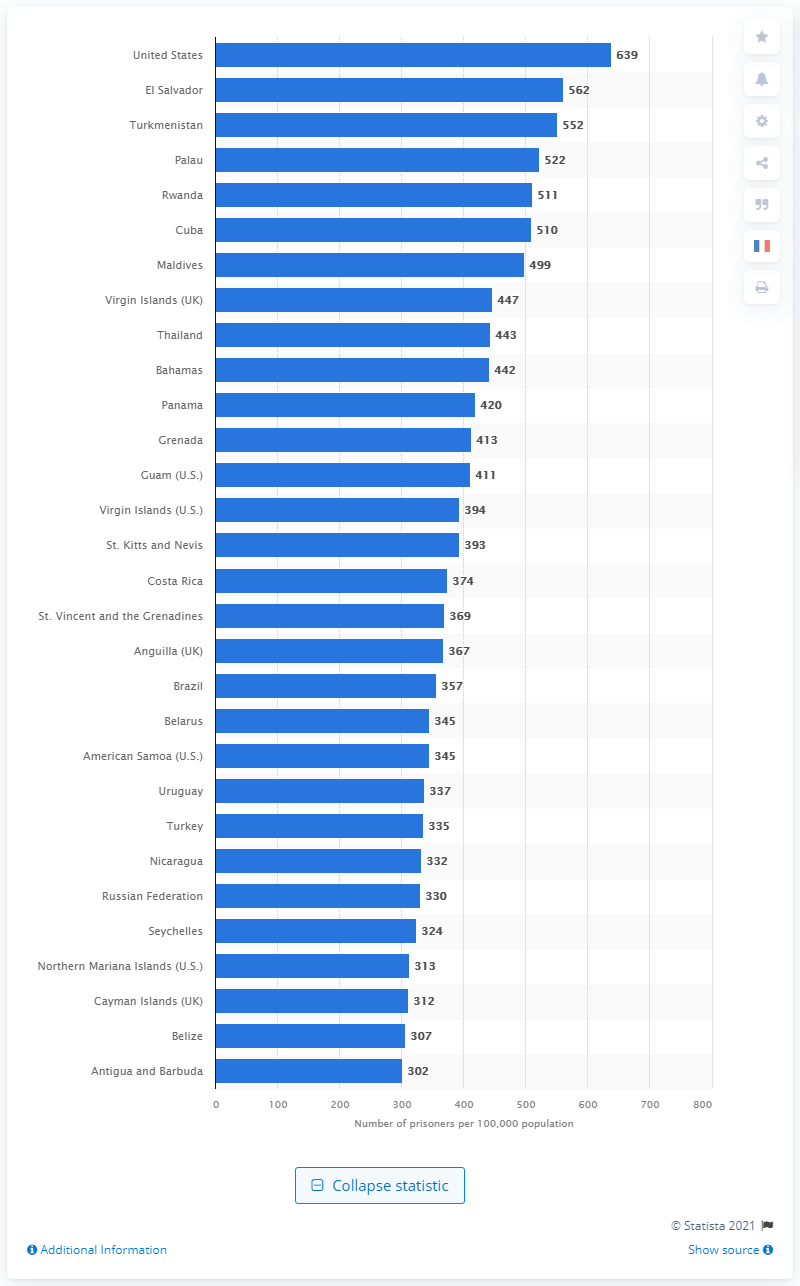Indicate a few pertinent items in this graphic. In May 2021, the United States had 639 prisoners per 100,000 of its population. 